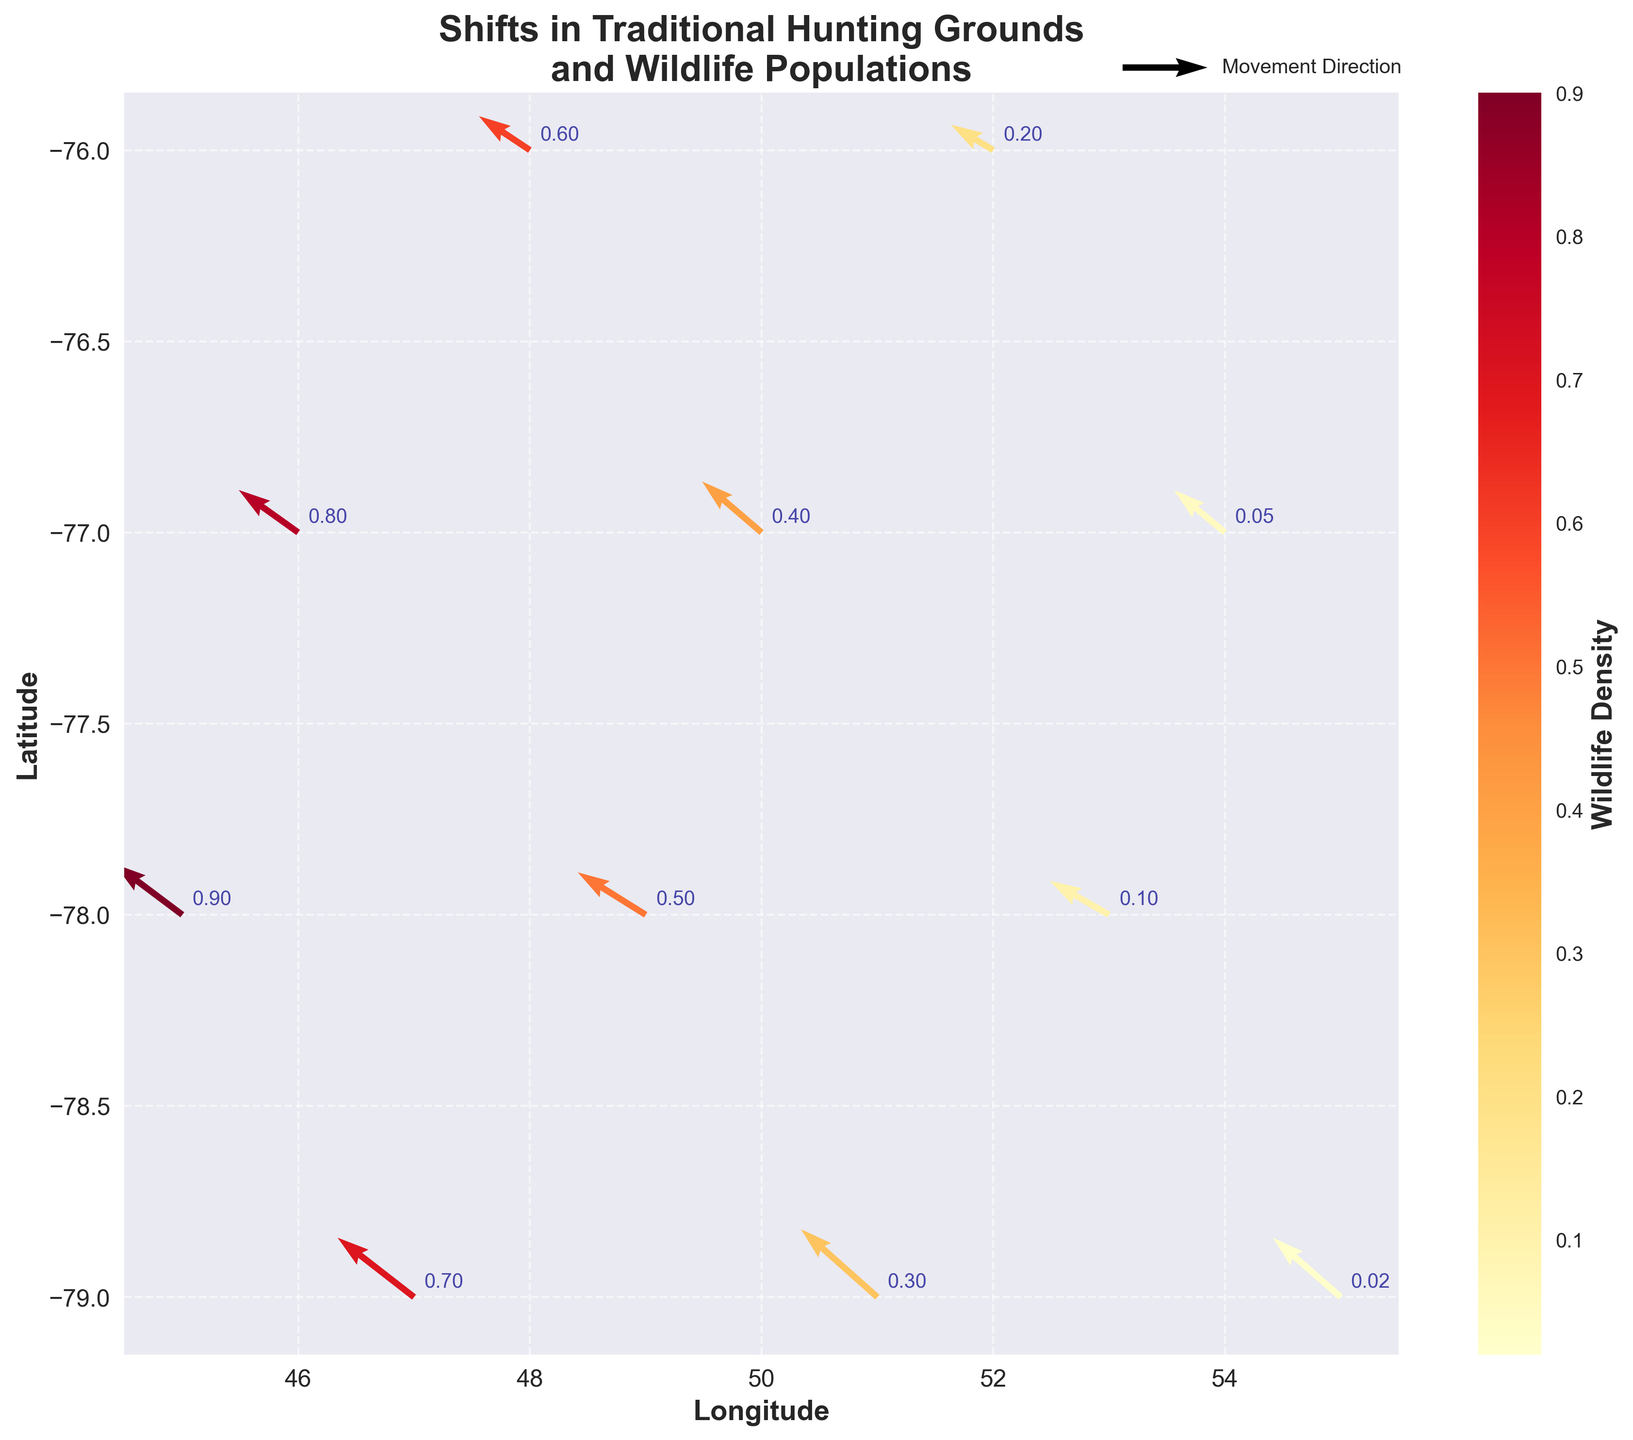What is the title of the figure? The title is usually found at the top of the figure. It serves as a description of what the figure is about.
Answer: Shifts in Traditional Hunting Grounds and Wildlife Populations Which axis represents the latitude? Look at the axis labels to determine which one indicates latitude. In this figure, the latitude is on the y-axis.
Answer: y-axis What does the color of the arrows represent? The color of the arrows is indicated by the colorbar. It represents wildlife density, with different colors showing different densities.
Answer: Wildlife Density How many data points are shown in the figure? Count the number of arrows shown in the quiver plot to determine the number of data points.
Answer: 11 Which coordinate has the highest wildlife density, and what is its value? Check the annotations near the arrows to find the coordinate with the highest density value. The arrow at (45,-78) has a density value of 0.9.
Answer: (45, -78), 0.9 What is the general direction of the movement patterns shown in the plot? Analyze the arrows to understand the overall movement trend. Most arrows are pointing towards the northeast.
Answer: Northeast Which location has the lowest wildlife density, and what is its value? Find the arrow with the smallest density annotation. The arrow at (55,-79) has the lowest density value of 0.02.
Answer: (55, -79), 0.02 What is the average wildlife density across all data points? Sum all density values and divide by the number of data points: (0.9 + 0.8 + 0.7 + 0.6 + 0.5 + 0.4 + 0.3 + 0.2 + 0.1 + 0.05 + 0.02) / 11 = 4.87 / 11 = 0.4427
Answer: 0.443 What is the range of wildlife densities depicted in the plot? Determine the highest and lowest density values and subtract the smallest from the largest: 0.9 - 0.02 = 0.88
Answer: 0.88 How do the movement directions correlate with wildlife density? Compare the direction of arrows with their corresponding densities. Higher densities tend to have more northwest direction, while lower densities are more dispersed.
Answer: Higher density: NW, Lower density: dispersed 